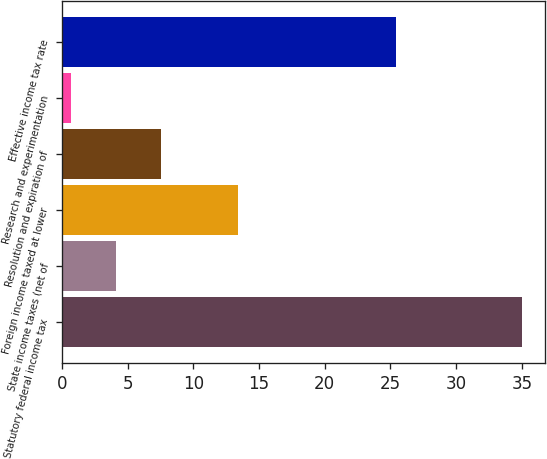<chart> <loc_0><loc_0><loc_500><loc_500><bar_chart><fcel>Statutory federal income tax<fcel>State income taxes (net of<fcel>Foreign income taxed at lower<fcel>Resolution and expiration of<fcel>Research and experimentation<fcel>Effective income tax rate<nl><fcel>35<fcel>4.13<fcel>13.4<fcel>7.56<fcel>0.7<fcel>25.4<nl></chart> 